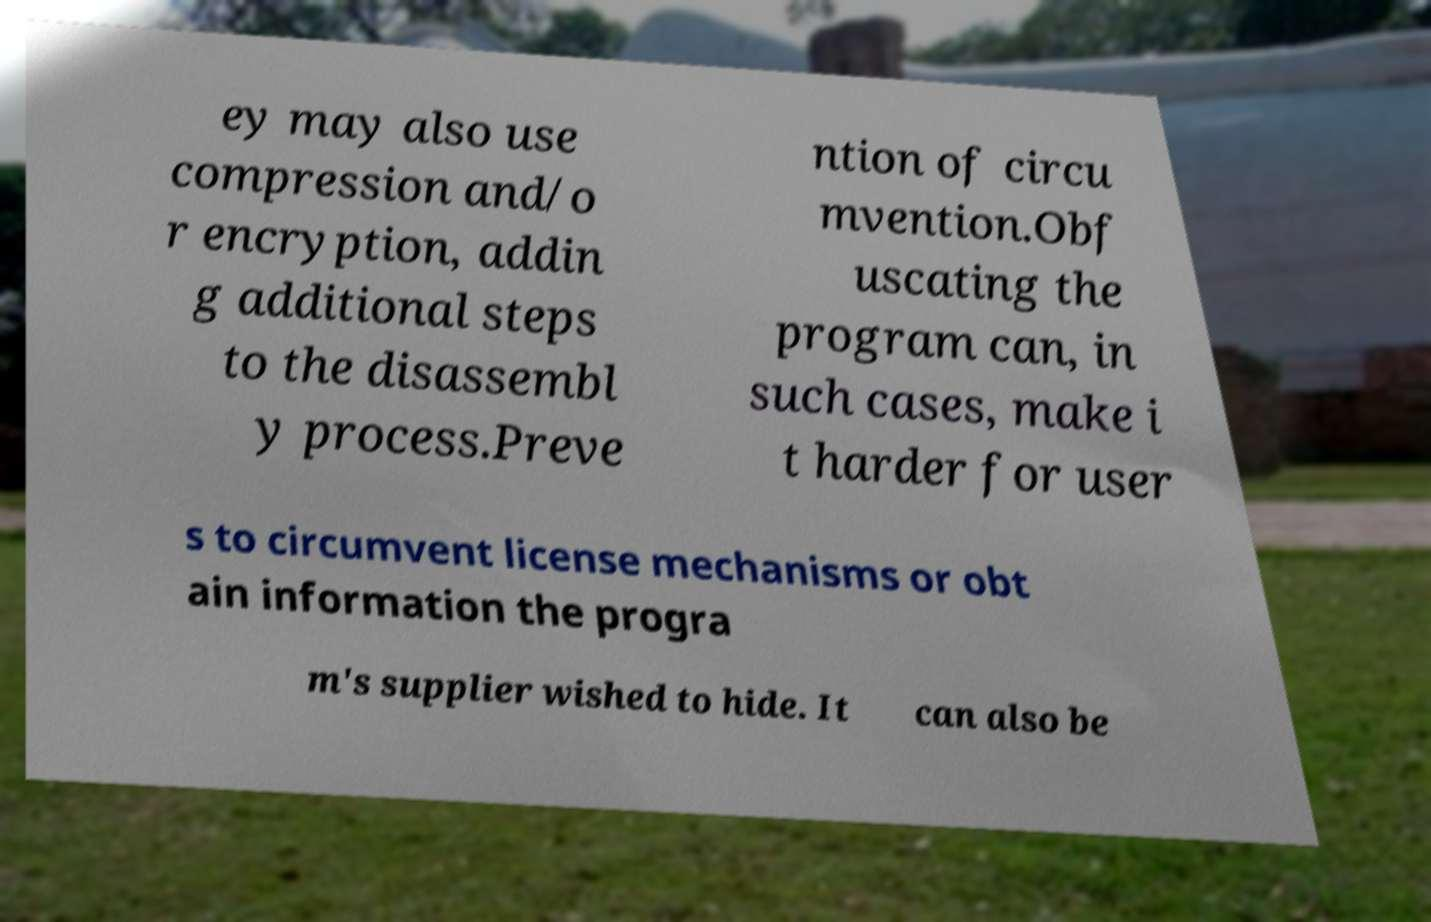Please read and relay the text visible in this image. What does it say? ey may also use compression and/o r encryption, addin g additional steps to the disassembl y process.Preve ntion of circu mvention.Obf uscating the program can, in such cases, make i t harder for user s to circumvent license mechanisms or obt ain information the progra m's supplier wished to hide. It can also be 